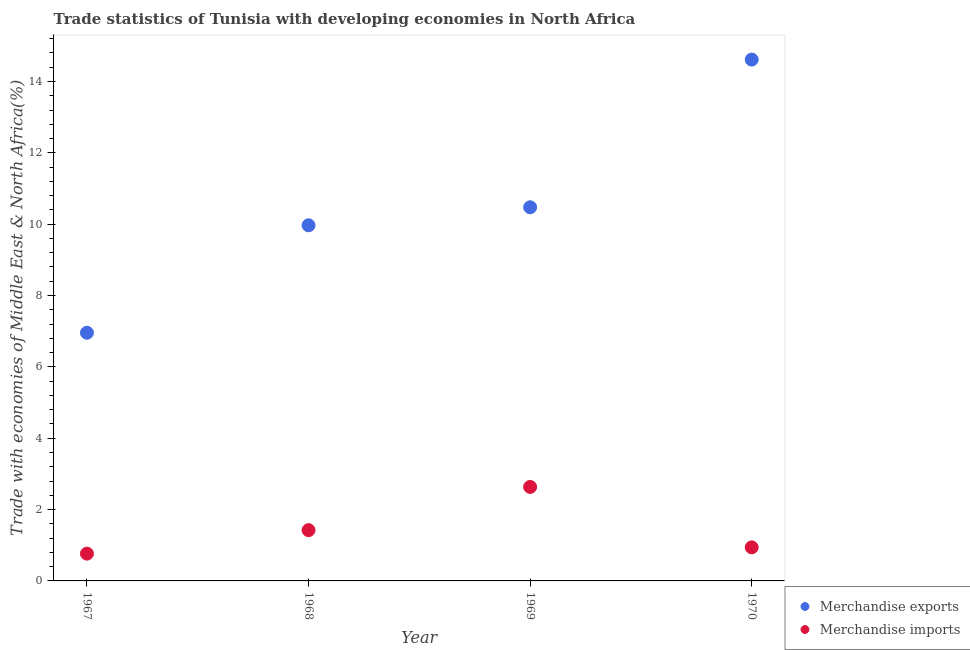How many different coloured dotlines are there?
Make the answer very short. 2. What is the merchandise imports in 1967?
Keep it short and to the point. 0.77. Across all years, what is the maximum merchandise exports?
Give a very brief answer. 14.61. Across all years, what is the minimum merchandise imports?
Make the answer very short. 0.77. In which year was the merchandise imports minimum?
Your answer should be very brief. 1967. What is the total merchandise exports in the graph?
Your answer should be compact. 42.01. What is the difference between the merchandise exports in 1967 and that in 1969?
Your answer should be very brief. -3.52. What is the difference between the merchandise exports in 1968 and the merchandise imports in 1970?
Give a very brief answer. 9.03. What is the average merchandise imports per year?
Provide a short and direct response. 1.44. In the year 1968, what is the difference between the merchandise exports and merchandise imports?
Provide a succinct answer. 8.55. What is the ratio of the merchandise exports in 1968 to that in 1970?
Your answer should be very brief. 0.68. Is the merchandise exports in 1967 less than that in 1970?
Keep it short and to the point. Yes. What is the difference between the highest and the second highest merchandise exports?
Make the answer very short. 4.14. What is the difference between the highest and the lowest merchandise imports?
Your answer should be compact. 1.87. In how many years, is the merchandise exports greater than the average merchandise exports taken over all years?
Your answer should be very brief. 1. Is the sum of the merchandise exports in 1967 and 1970 greater than the maximum merchandise imports across all years?
Offer a very short reply. Yes. Is the merchandise imports strictly greater than the merchandise exports over the years?
Ensure brevity in your answer.  No. Is the merchandise exports strictly less than the merchandise imports over the years?
Offer a very short reply. No. Are the values on the major ticks of Y-axis written in scientific E-notation?
Ensure brevity in your answer.  No. Does the graph contain any zero values?
Ensure brevity in your answer.  No. Does the graph contain grids?
Offer a very short reply. No. Where does the legend appear in the graph?
Your response must be concise. Bottom right. How many legend labels are there?
Your answer should be compact. 2. What is the title of the graph?
Offer a very short reply. Trade statistics of Tunisia with developing economies in North Africa. What is the label or title of the Y-axis?
Your response must be concise. Trade with economies of Middle East & North Africa(%). What is the Trade with economies of Middle East & North Africa(%) of Merchandise exports in 1967?
Provide a short and direct response. 6.96. What is the Trade with economies of Middle East & North Africa(%) in Merchandise imports in 1967?
Provide a succinct answer. 0.77. What is the Trade with economies of Middle East & North Africa(%) of Merchandise exports in 1968?
Keep it short and to the point. 9.97. What is the Trade with economies of Middle East & North Africa(%) of Merchandise imports in 1968?
Give a very brief answer. 1.42. What is the Trade with economies of Middle East & North Africa(%) of Merchandise exports in 1969?
Offer a very short reply. 10.47. What is the Trade with economies of Middle East & North Africa(%) of Merchandise imports in 1969?
Provide a succinct answer. 2.63. What is the Trade with economies of Middle East & North Africa(%) of Merchandise exports in 1970?
Offer a terse response. 14.61. What is the Trade with economies of Middle East & North Africa(%) in Merchandise imports in 1970?
Ensure brevity in your answer.  0.94. Across all years, what is the maximum Trade with economies of Middle East & North Africa(%) in Merchandise exports?
Your answer should be very brief. 14.61. Across all years, what is the maximum Trade with economies of Middle East & North Africa(%) of Merchandise imports?
Keep it short and to the point. 2.63. Across all years, what is the minimum Trade with economies of Middle East & North Africa(%) of Merchandise exports?
Give a very brief answer. 6.96. Across all years, what is the minimum Trade with economies of Middle East & North Africa(%) in Merchandise imports?
Provide a succinct answer. 0.77. What is the total Trade with economies of Middle East & North Africa(%) of Merchandise exports in the graph?
Make the answer very short. 42.01. What is the total Trade with economies of Middle East & North Africa(%) of Merchandise imports in the graph?
Offer a terse response. 5.76. What is the difference between the Trade with economies of Middle East & North Africa(%) in Merchandise exports in 1967 and that in 1968?
Ensure brevity in your answer.  -3.01. What is the difference between the Trade with economies of Middle East & North Africa(%) of Merchandise imports in 1967 and that in 1968?
Keep it short and to the point. -0.66. What is the difference between the Trade with economies of Middle East & North Africa(%) of Merchandise exports in 1967 and that in 1969?
Offer a very short reply. -3.52. What is the difference between the Trade with economies of Middle East & North Africa(%) in Merchandise imports in 1967 and that in 1969?
Provide a succinct answer. -1.87. What is the difference between the Trade with economies of Middle East & North Africa(%) of Merchandise exports in 1967 and that in 1970?
Your answer should be compact. -7.66. What is the difference between the Trade with economies of Middle East & North Africa(%) of Merchandise imports in 1967 and that in 1970?
Ensure brevity in your answer.  -0.18. What is the difference between the Trade with economies of Middle East & North Africa(%) of Merchandise exports in 1968 and that in 1969?
Offer a terse response. -0.5. What is the difference between the Trade with economies of Middle East & North Africa(%) of Merchandise imports in 1968 and that in 1969?
Keep it short and to the point. -1.21. What is the difference between the Trade with economies of Middle East & North Africa(%) in Merchandise exports in 1968 and that in 1970?
Your answer should be compact. -4.64. What is the difference between the Trade with economies of Middle East & North Africa(%) in Merchandise imports in 1968 and that in 1970?
Make the answer very short. 0.48. What is the difference between the Trade with economies of Middle East & North Africa(%) of Merchandise exports in 1969 and that in 1970?
Ensure brevity in your answer.  -4.14. What is the difference between the Trade with economies of Middle East & North Africa(%) of Merchandise imports in 1969 and that in 1970?
Keep it short and to the point. 1.69. What is the difference between the Trade with economies of Middle East & North Africa(%) in Merchandise exports in 1967 and the Trade with economies of Middle East & North Africa(%) in Merchandise imports in 1968?
Ensure brevity in your answer.  5.53. What is the difference between the Trade with economies of Middle East & North Africa(%) of Merchandise exports in 1967 and the Trade with economies of Middle East & North Africa(%) of Merchandise imports in 1969?
Offer a very short reply. 4.32. What is the difference between the Trade with economies of Middle East & North Africa(%) in Merchandise exports in 1967 and the Trade with economies of Middle East & North Africa(%) in Merchandise imports in 1970?
Keep it short and to the point. 6.02. What is the difference between the Trade with economies of Middle East & North Africa(%) of Merchandise exports in 1968 and the Trade with economies of Middle East & North Africa(%) of Merchandise imports in 1969?
Provide a short and direct response. 7.33. What is the difference between the Trade with economies of Middle East & North Africa(%) in Merchandise exports in 1968 and the Trade with economies of Middle East & North Africa(%) in Merchandise imports in 1970?
Your response must be concise. 9.03. What is the difference between the Trade with economies of Middle East & North Africa(%) in Merchandise exports in 1969 and the Trade with economies of Middle East & North Africa(%) in Merchandise imports in 1970?
Offer a terse response. 9.53. What is the average Trade with economies of Middle East & North Africa(%) in Merchandise exports per year?
Give a very brief answer. 10.5. What is the average Trade with economies of Middle East & North Africa(%) of Merchandise imports per year?
Offer a very short reply. 1.44. In the year 1967, what is the difference between the Trade with economies of Middle East & North Africa(%) in Merchandise exports and Trade with economies of Middle East & North Africa(%) in Merchandise imports?
Offer a terse response. 6.19. In the year 1968, what is the difference between the Trade with economies of Middle East & North Africa(%) of Merchandise exports and Trade with economies of Middle East & North Africa(%) of Merchandise imports?
Give a very brief answer. 8.55. In the year 1969, what is the difference between the Trade with economies of Middle East & North Africa(%) in Merchandise exports and Trade with economies of Middle East & North Africa(%) in Merchandise imports?
Make the answer very short. 7.84. In the year 1970, what is the difference between the Trade with economies of Middle East & North Africa(%) in Merchandise exports and Trade with economies of Middle East & North Africa(%) in Merchandise imports?
Your answer should be compact. 13.67. What is the ratio of the Trade with economies of Middle East & North Africa(%) of Merchandise exports in 1967 to that in 1968?
Keep it short and to the point. 0.7. What is the ratio of the Trade with economies of Middle East & North Africa(%) in Merchandise imports in 1967 to that in 1968?
Provide a short and direct response. 0.54. What is the ratio of the Trade with economies of Middle East & North Africa(%) of Merchandise exports in 1967 to that in 1969?
Offer a terse response. 0.66. What is the ratio of the Trade with economies of Middle East & North Africa(%) in Merchandise imports in 1967 to that in 1969?
Your response must be concise. 0.29. What is the ratio of the Trade with economies of Middle East & North Africa(%) in Merchandise exports in 1967 to that in 1970?
Ensure brevity in your answer.  0.48. What is the ratio of the Trade with economies of Middle East & North Africa(%) of Merchandise imports in 1967 to that in 1970?
Provide a succinct answer. 0.81. What is the ratio of the Trade with economies of Middle East & North Africa(%) of Merchandise exports in 1968 to that in 1969?
Make the answer very short. 0.95. What is the ratio of the Trade with economies of Middle East & North Africa(%) in Merchandise imports in 1968 to that in 1969?
Make the answer very short. 0.54. What is the ratio of the Trade with economies of Middle East & North Africa(%) of Merchandise exports in 1968 to that in 1970?
Your response must be concise. 0.68. What is the ratio of the Trade with economies of Middle East & North Africa(%) of Merchandise imports in 1968 to that in 1970?
Your answer should be very brief. 1.51. What is the ratio of the Trade with economies of Middle East & North Africa(%) in Merchandise exports in 1969 to that in 1970?
Your response must be concise. 0.72. What is the ratio of the Trade with economies of Middle East & North Africa(%) of Merchandise imports in 1969 to that in 1970?
Make the answer very short. 2.8. What is the difference between the highest and the second highest Trade with economies of Middle East & North Africa(%) in Merchandise exports?
Your answer should be very brief. 4.14. What is the difference between the highest and the second highest Trade with economies of Middle East & North Africa(%) in Merchandise imports?
Keep it short and to the point. 1.21. What is the difference between the highest and the lowest Trade with economies of Middle East & North Africa(%) in Merchandise exports?
Ensure brevity in your answer.  7.66. What is the difference between the highest and the lowest Trade with economies of Middle East & North Africa(%) of Merchandise imports?
Keep it short and to the point. 1.87. 